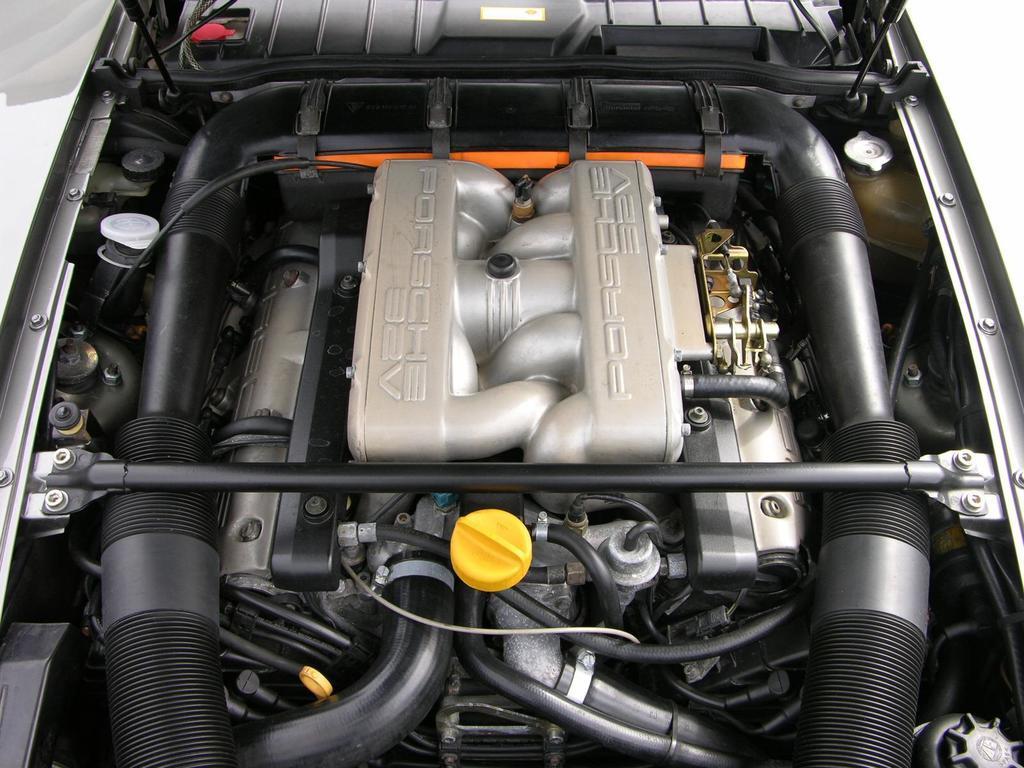Can you describe this image briefly? In this image we can see the car engine. 